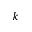<formula> <loc_0><loc_0><loc_500><loc_500>k</formula> 